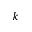<formula> <loc_0><loc_0><loc_500><loc_500>k</formula> 